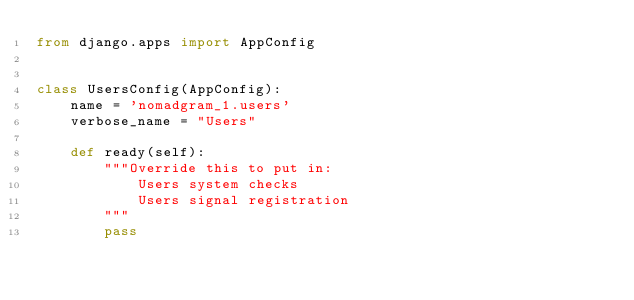<code> <loc_0><loc_0><loc_500><loc_500><_Python_>from django.apps import AppConfig


class UsersConfig(AppConfig):
    name = 'nomadgram_1.users'
    verbose_name = "Users"

    def ready(self):
        """Override this to put in:
            Users system checks
            Users signal registration
        """
        pass
</code> 